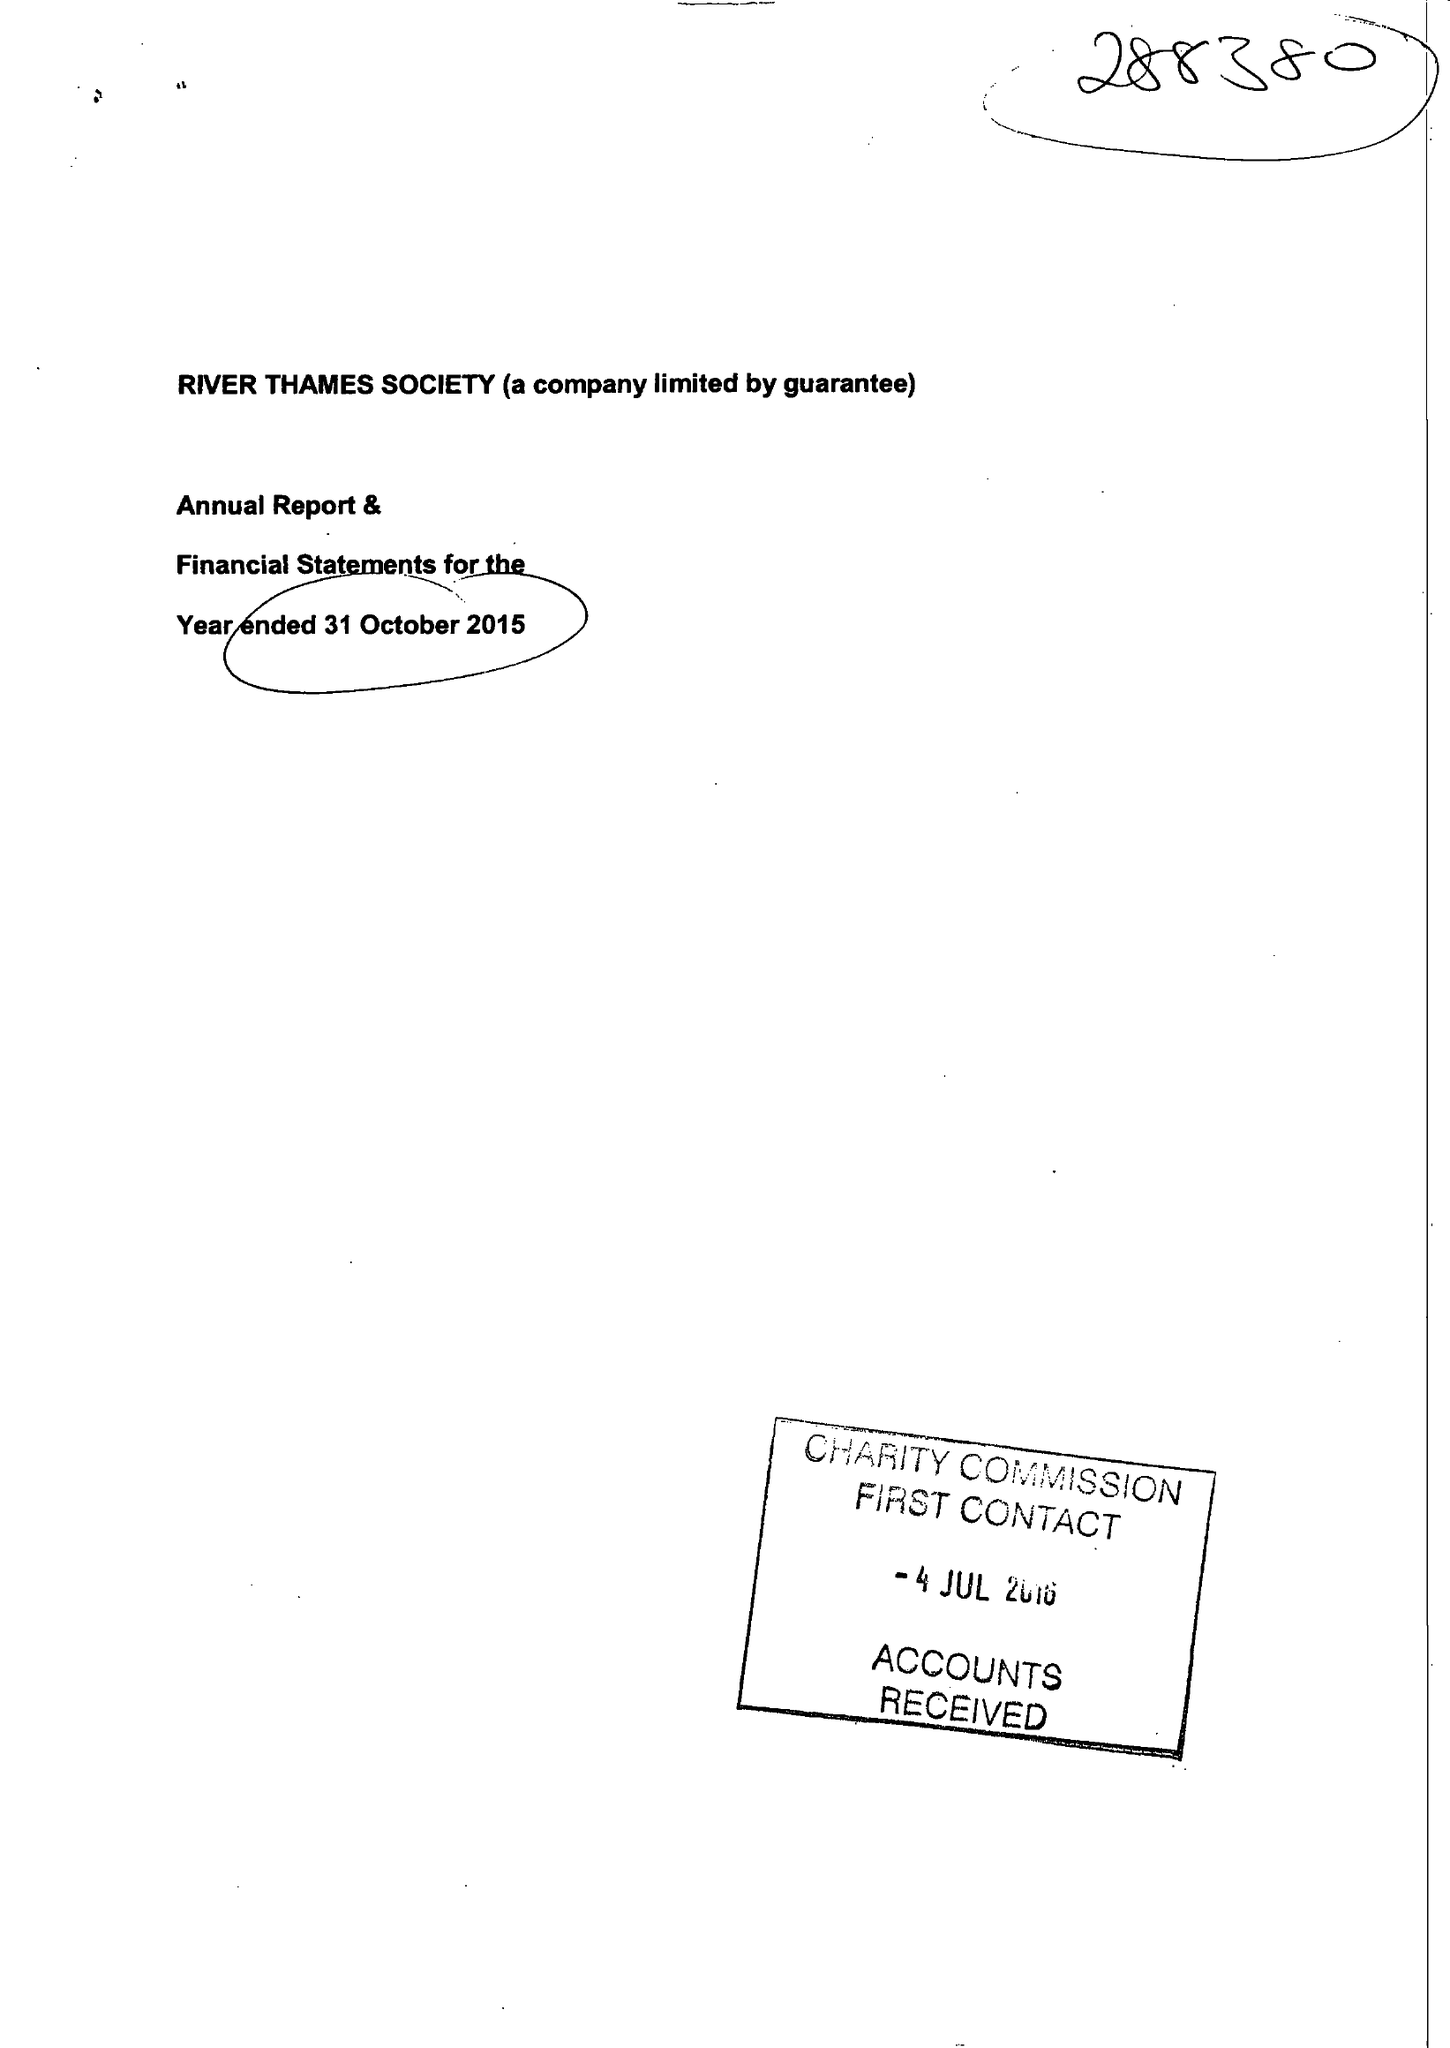What is the value for the charity_name?
Answer the question using a single word or phrase. River Thames Society 